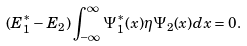Convert formula to latex. <formula><loc_0><loc_0><loc_500><loc_500>( E ^ { \ast } _ { 1 } - E _ { 2 } ) \int _ { - \infty } ^ { \infty } \Psi ^ { \ast } _ { 1 } ( x ) \eta \Psi _ { 2 } ( x ) d x = 0 .</formula> 